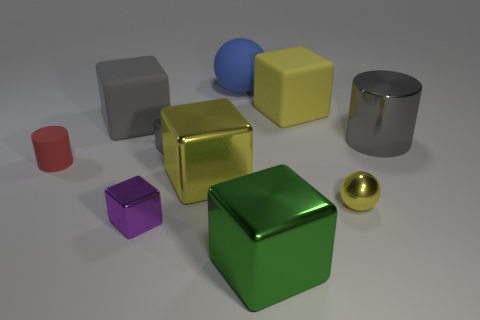What is the color of the sphere that is behind the large object to the left of the tiny object in front of the yellow metallic sphere?
Ensure brevity in your answer.  Blue. What color is the metallic cylinder that is the same size as the green shiny cube?
Offer a very short reply. Gray. What number of metallic objects are large green things or large gray cylinders?
Offer a terse response. 2. What is the color of the large cylinder that is made of the same material as the purple object?
Offer a very short reply. Gray. There is a gray cylinder that is to the right of the small object that is to the right of the blue matte thing; what is its material?
Provide a short and direct response. Metal. How many objects are either large cubes behind the large yellow metal block or tiny metal blocks in front of the red matte object?
Offer a very short reply. 3. What is the size of the rubber block on the left side of the tiny purple object left of the yellow metallic object left of the small yellow sphere?
Give a very brief answer. Large. Are there an equal number of big gray metallic cylinders that are to the left of the large gray cylinder and blue things?
Provide a short and direct response. No. Is there any other thing that is the same shape as the big yellow metallic object?
Provide a short and direct response. Yes. Is the shape of the red matte object the same as the yellow thing behind the tiny gray metallic cube?
Provide a short and direct response. No. 